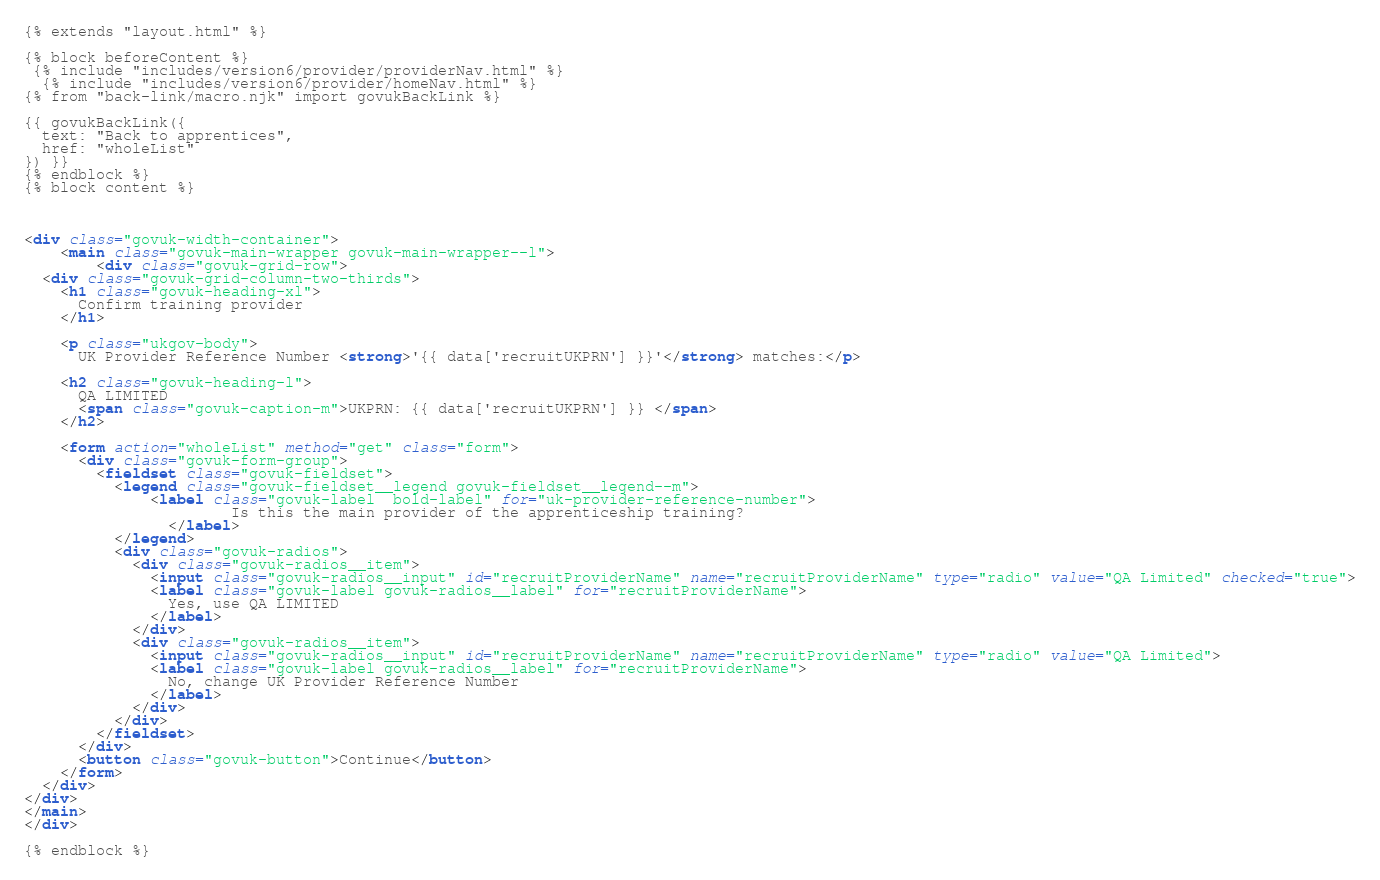<code> <loc_0><loc_0><loc_500><loc_500><_HTML_>{% extends "layout.html" %}

{% block beforeContent %}
 {% include "includes/version6/provider/providerNav.html" %}
  {% include "includes/version6/provider/homeNav.html" %}
{% from "back-link/macro.njk" import govukBackLink %}

{{ govukBackLink({
  text: "Back to apprentices",
  href: "wholeList"
}) }}
{% endblock %}
{% block content %}



<div class="govuk-width-container">
    <main class="govuk-main-wrapper govuk-main-wrapper--l">
        <div class="govuk-grid-row">
  <div class="govuk-grid-column-two-thirds">
    <h1 class="govuk-heading-xl">
      Confirm training provider
    </h1>

    <p class="ukgov-body">
      UK Provider Reference Number <strong>'{{ data['recruitUKPRN'] }}'</strong> matches:</p>

    <h2 class="govuk-heading-l">
      QA LIMITED
      <span class="govuk-caption-m">UKPRN: {{ data['recruitUKPRN'] }} </span>
    </h2>

    <form action="wholeList" method="get" class="form">
      <div class="govuk-form-group">
        <fieldset class="govuk-fieldset">
          <legend class="govuk-fieldset__legend govuk-fieldset__legend--m">
              <label class="govuk-label  bold-label" for="uk-provider-reference-number">
                       Is this the main provider of the apprenticeship training?
                </label>   
          </legend>
          <div class="govuk-radios">
            <div class="govuk-radios__item">
              <input class="govuk-radios__input" id="recruitProviderName" name="recruitProviderName" type="radio" value="QA Limited" checked="true">
              <label class="govuk-label govuk-radios__label" for="recruitProviderName">
                Yes, use QA LIMITED
              </label>
            </div>
            <div class="govuk-radios__item">
              <input class="govuk-radios__input" id="recruitProviderName" name="recruitProviderName" type="radio" value="QA Limited">
              <label class="govuk-label govuk-radios__label" for="recruitProviderName">
                No, change UK Provider Reference Number
              </label>
            </div>
          </div>
        </fieldset>
      </div>
      <button class="govuk-button">Continue</button>
    </form>
  </div>
</div>
</main>
</div>

{% endblock %}</code> 